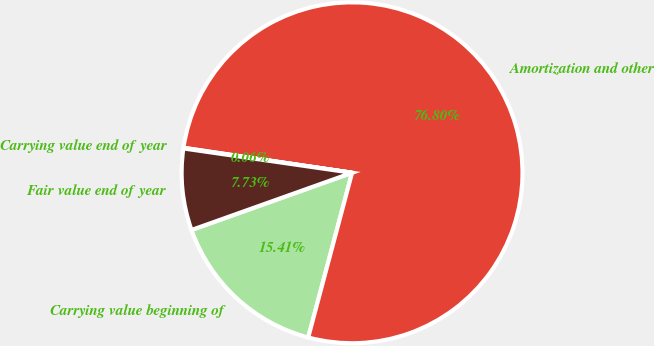Convert chart. <chart><loc_0><loc_0><loc_500><loc_500><pie_chart><fcel>Carrying value beginning of<fcel>Amortization and other<fcel>Carrying value end of year<fcel>Fair value end of year<nl><fcel>15.41%<fcel>76.8%<fcel>0.06%<fcel>7.73%<nl></chart> 